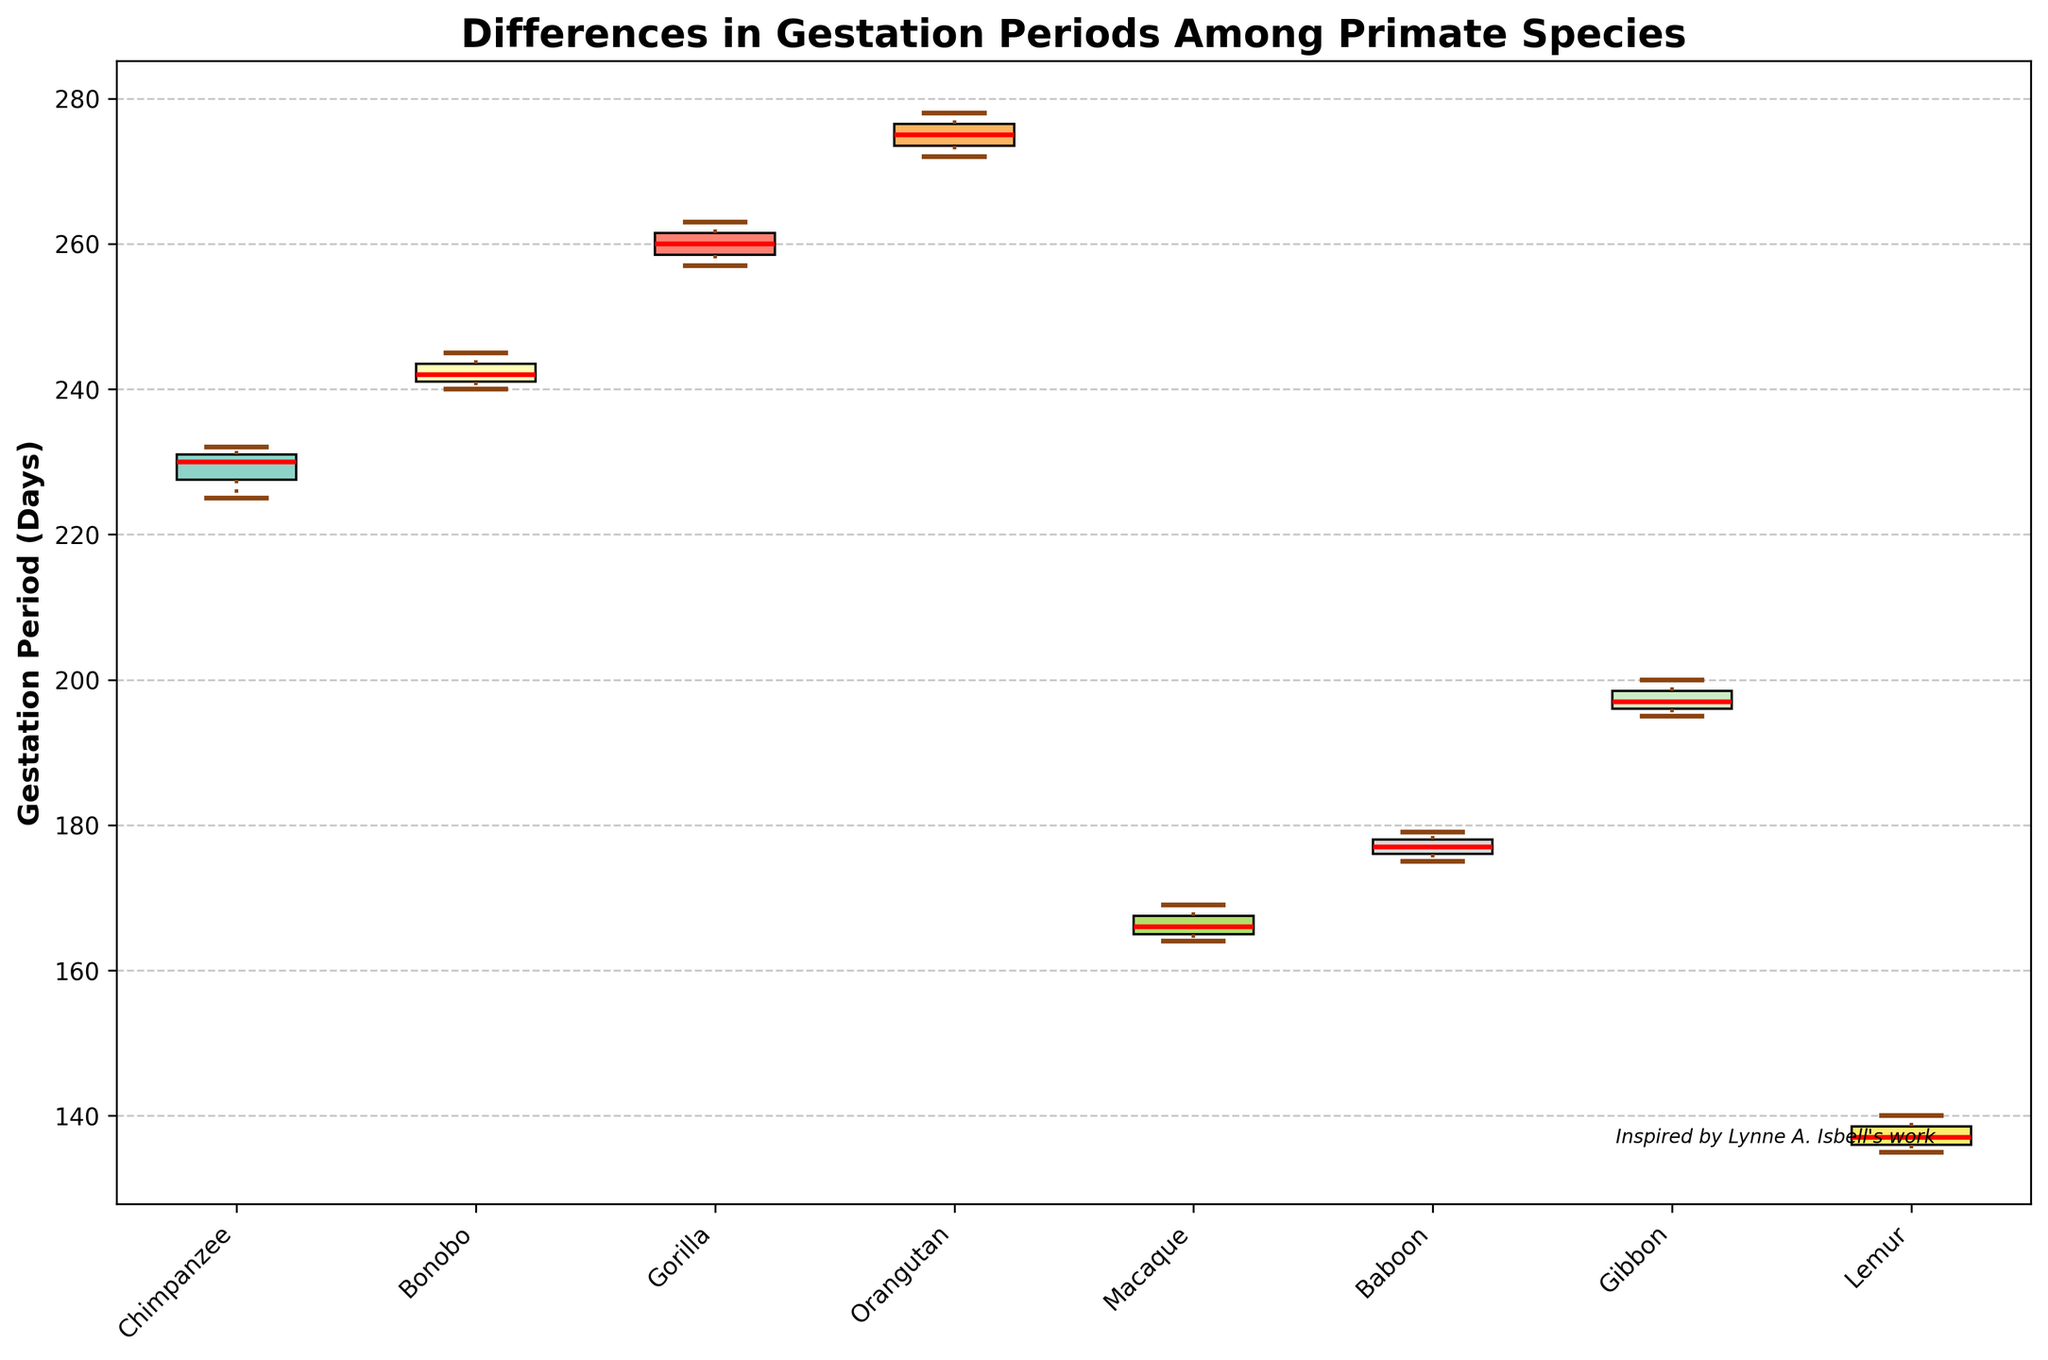What is the title of the box plot? The title is found at the top of the figure. It helps identify what the graph is about.
Answer: Differences in Gestation Periods Among Primate Species How many species are compared in the box plot? Count the number of distinct labels along the x-axis. Each label represents a species.
Answer: 7 What is the median gestation period for Gorillas? Locate the box for Gorillas and identify the line within the box which represents the median.
Answer: 260 days Which species has the shortest median gestation period? Compare the medians of all species, looking for the one with the lowest value.
Answer: Lemur What is the interquartile range (IQR) for Chimpanzees? The IQR is the difference between the third quartile (upper edge of the box) and the first quartile (lower edge of the box) for the Chimpanzees. You need to estimate these values from the plot.
Answer: 7 days Which species has the widest range in gestation periods? The range is determined by the distance between the top of the upper whisker and the bottom of the lower whisker. Look for the species with the largest span.
Answer: Orangutan For which species are there outliers? Outliers are typically marked with special symbols (like circles) outside the whiskers. Identify where these symbols appear.
Answer: None Which species has the highest maximum gestation period? Find the species with the highest point reached by their upper whisker.
Answer: Orangutan What is the approximate lower whisker value for Gibbons? Identify the lower whisker for Gibbons and estimate its value based on the y-axis.
Answer: Approximately 193 days Which species has the smallest interquartile range (IQR)? Compare the lengths of the boxes (distance from the first to the third quartile) for each species to find the smallest.
Answer: Chimpanzee 